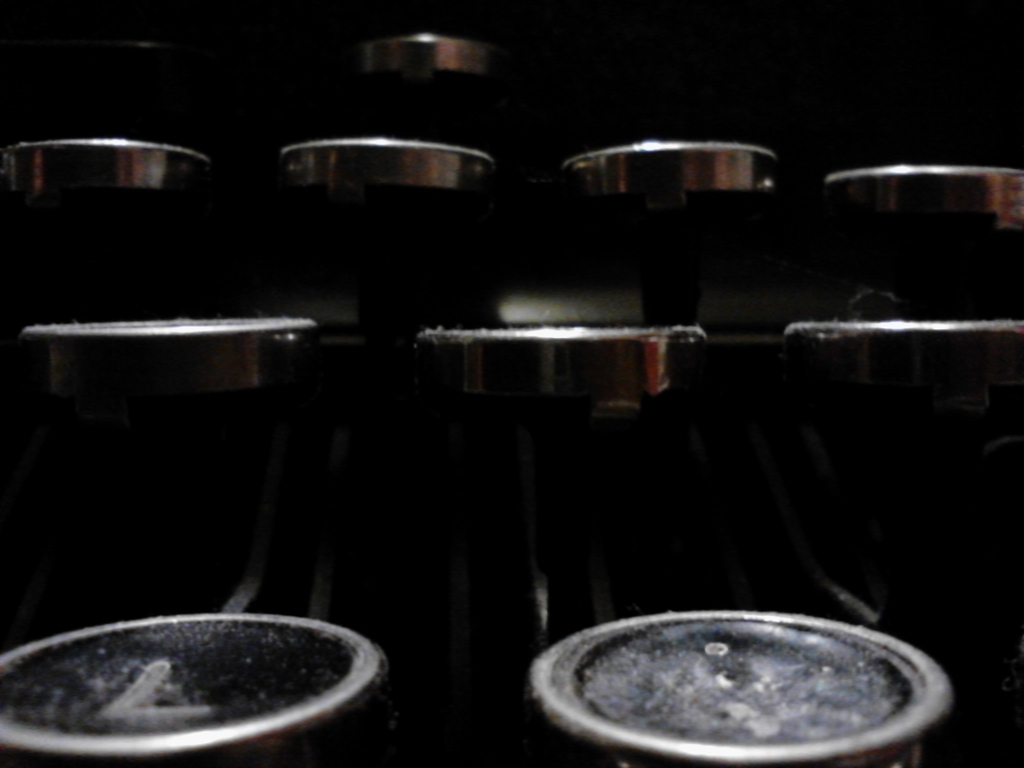Can you describe the objects in this image and their potential use? The objects in the image appear to be cylindrical metal knobs or dials, commonly found on electronic or mechanical devices. They could be part of a musical instrument, such as a synthesizer or mixing console, used to adjust volume, tone, or other audio properties. 